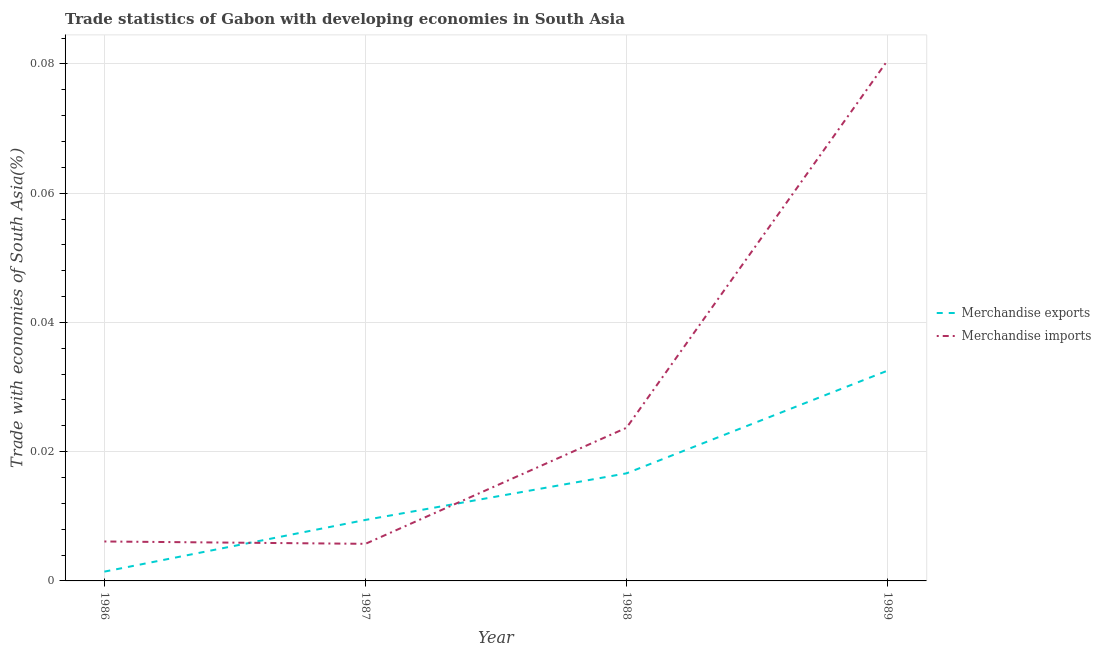How many different coloured lines are there?
Offer a terse response. 2. What is the merchandise exports in 1989?
Give a very brief answer. 0.03. Across all years, what is the maximum merchandise imports?
Your answer should be very brief. 0.08. Across all years, what is the minimum merchandise exports?
Your answer should be very brief. 0. What is the total merchandise imports in the graph?
Your answer should be very brief. 0.12. What is the difference between the merchandise exports in 1988 and that in 1989?
Your response must be concise. -0.02. What is the difference between the merchandise imports in 1988 and the merchandise exports in 1987?
Offer a very short reply. 0.01. What is the average merchandise exports per year?
Keep it short and to the point. 0.02. In the year 1986, what is the difference between the merchandise exports and merchandise imports?
Your answer should be compact. -0. What is the ratio of the merchandise exports in 1987 to that in 1989?
Make the answer very short. 0.29. Is the difference between the merchandise exports in 1987 and 1989 greater than the difference between the merchandise imports in 1987 and 1989?
Ensure brevity in your answer.  Yes. What is the difference between the highest and the second highest merchandise exports?
Provide a short and direct response. 0.02. What is the difference between the highest and the lowest merchandise imports?
Give a very brief answer. 0.07. Is the merchandise exports strictly less than the merchandise imports over the years?
Make the answer very short. No. How many lines are there?
Your answer should be very brief. 2. What is the difference between two consecutive major ticks on the Y-axis?
Provide a short and direct response. 0.02. Does the graph contain any zero values?
Make the answer very short. No. Does the graph contain grids?
Make the answer very short. Yes. Where does the legend appear in the graph?
Provide a succinct answer. Center right. How many legend labels are there?
Ensure brevity in your answer.  2. What is the title of the graph?
Keep it short and to the point. Trade statistics of Gabon with developing economies in South Asia. Does "Overweight" appear as one of the legend labels in the graph?
Provide a succinct answer. No. What is the label or title of the X-axis?
Your answer should be compact. Year. What is the label or title of the Y-axis?
Make the answer very short. Trade with economies of South Asia(%). What is the Trade with economies of South Asia(%) in Merchandise exports in 1986?
Provide a short and direct response. 0. What is the Trade with economies of South Asia(%) of Merchandise imports in 1986?
Make the answer very short. 0.01. What is the Trade with economies of South Asia(%) of Merchandise exports in 1987?
Ensure brevity in your answer.  0.01. What is the Trade with economies of South Asia(%) of Merchandise imports in 1987?
Ensure brevity in your answer.  0.01. What is the Trade with economies of South Asia(%) in Merchandise exports in 1988?
Provide a succinct answer. 0.02. What is the Trade with economies of South Asia(%) of Merchandise imports in 1988?
Your answer should be very brief. 0.02. What is the Trade with economies of South Asia(%) of Merchandise exports in 1989?
Your answer should be very brief. 0.03. What is the Trade with economies of South Asia(%) in Merchandise imports in 1989?
Your response must be concise. 0.08. Across all years, what is the maximum Trade with economies of South Asia(%) of Merchandise exports?
Your response must be concise. 0.03. Across all years, what is the maximum Trade with economies of South Asia(%) in Merchandise imports?
Ensure brevity in your answer.  0.08. Across all years, what is the minimum Trade with economies of South Asia(%) in Merchandise exports?
Make the answer very short. 0. Across all years, what is the minimum Trade with economies of South Asia(%) of Merchandise imports?
Offer a very short reply. 0.01. What is the total Trade with economies of South Asia(%) in Merchandise exports in the graph?
Your response must be concise. 0.06. What is the total Trade with economies of South Asia(%) of Merchandise imports in the graph?
Give a very brief answer. 0.12. What is the difference between the Trade with economies of South Asia(%) in Merchandise exports in 1986 and that in 1987?
Provide a succinct answer. -0.01. What is the difference between the Trade with economies of South Asia(%) in Merchandise exports in 1986 and that in 1988?
Your answer should be very brief. -0.02. What is the difference between the Trade with economies of South Asia(%) of Merchandise imports in 1986 and that in 1988?
Make the answer very short. -0.02. What is the difference between the Trade with economies of South Asia(%) of Merchandise exports in 1986 and that in 1989?
Ensure brevity in your answer.  -0.03. What is the difference between the Trade with economies of South Asia(%) of Merchandise imports in 1986 and that in 1989?
Make the answer very short. -0.07. What is the difference between the Trade with economies of South Asia(%) in Merchandise exports in 1987 and that in 1988?
Your answer should be compact. -0.01. What is the difference between the Trade with economies of South Asia(%) in Merchandise imports in 1987 and that in 1988?
Make the answer very short. -0.02. What is the difference between the Trade with economies of South Asia(%) in Merchandise exports in 1987 and that in 1989?
Offer a terse response. -0.02. What is the difference between the Trade with economies of South Asia(%) of Merchandise imports in 1987 and that in 1989?
Keep it short and to the point. -0.07. What is the difference between the Trade with economies of South Asia(%) in Merchandise exports in 1988 and that in 1989?
Keep it short and to the point. -0.02. What is the difference between the Trade with economies of South Asia(%) in Merchandise imports in 1988 and that in 1989?
Ensure brevity in your answer.  -0.06. What is the difference between the Trade with economies of South Asia(%) in Merchandise exports in 1986 and the Trade with economies of South Asia(%) in Merchandise imports in 1987?
Keep it short and to the point. -0. What is the difference between the Trade with economies of South Asia(%) in Merchandise exports in 1986 and the Trade with economies of South Asia(%) in Merchandise imports in 1988?
Your answer should be very brief. -0.02. What is the difference between the Trade with economies of South Asia(%) of Merchandise exports in 1986 and the Trade with economies of South Asia(%) of Merchandise imports in 1989?
Your answer should be compact. -0.08. What is the difference between the Trade with economies of South Asia(%) in Merchandise exports in 1987 and the Trade with economies of South Asia(%) in Merchandise imports in 1988?
Give a very brief answer. -0.01. What is the difference between the Trade with economies of South Asia(%) in Merchandise exports in 1987 and the Trade with economies of South Asia(%) in Merchandise imports in 1989?
Your answer should be compact. -0.07. What is the difference between the Trade with economies of South Asia(%) of Merchandise exports in 1988 and the Trade with economies of South Asia(%) of Merchandise imports in 1989?
Offer a terse response. -0.06. What is the average Trade with economies of South Asia(%) in Merchandise exports per year?
Provide a succinct answer. 0.01. What is the average Trade with economies of South Asia(%) in Merchandise imports per year?
Keep it short and to the point. 0.03. In the year 1986, what is the difference between the Trade with economies of South Asia(%) in Merchandise exports and Trade with economies of South Asia(%) in Merchandise imports?
Your answer should be compact. -0. In the year 1987, what is the difference between the Trade with economies of South Asia(%) in Merchandise exports and Trade with economies of South Asia(%) in Merchandise imports?
Your response must be concise. 0. In the year 1988, what is the difference between the Trade with economies of South Asia(%) in Merchandise exports and Trade with economies of South Asia(%) in Merchandise imports?
Offer a terse response. -0.01. In the year 1989, what is the difference between the Trade with economies of South Asia(%) of Merchandise exports and Trade with economies of South Asia(%) of Merchandise imports?
Your response must be concise. -0.05. What is the ratio of the Trade with economies of South Asia(%) of Merchandise exports in 1986 to that in 1987?
Your answer should be very brief. 0.15. What is the ratio of the Trade with economies of South Asia(%) in Merchandise imports in 1986 to that in 1987?
Offer a very short reply. 1.06. What is the ratio of the Trade with economies of South Asia(%) in Merchandise exports in 1986 to that in 1988?
Your answer should be compact. 0.09. What is the ratio of the Trade with economies of South Asia(%) in Merchandise imports in 1986 to that in 1988?
Your answer should be very brief. 0.26. What is the ratio of the Trade with economies of South Asia(%) in Merchandise exports in 1986 to that in 1989?
Your answer should be very brief. 0.04. What is the ratio of the Trade with economies of South Asia(%) of Merchandise imports in 1986 to that in 1989?
Give a very brief answer. 0.08. What is the ratio of the Trade with economies of South Asia(%) of Merchandise exports in 1987 to that in 1988?
Offer a terse response. 0.57. What is the ratio of the Trade with economies of South Asia(%) of Merchandise imports in 1987 to that in 1988?
Keep it short and to the point. 0.24. What is the ratio of the Trade with economies of South Asia(%) in Merchandise exports in 1987 to that in 1989?
Offer a very short reply. 0.29. What is the ratio of the Trade with economies of South Asia(%) in Merchandise imports in 1987 to that in 1989?
Give a very brief answer. 0.07. What is the ratio of the Trade with economies of South Asia(%) of Merchandise exports in 1988 to that in 1989?
Your answer should be compact. 0.51. What is the ratio of the Trade with economies of South Asia(%) of Merchandise imports in 1988 to that in 1989?
Keep it short and to the point. 0.29. What is the difference between the highest and the second highest Trade with economies of South Asia(%) in Merchandise exports?
Your answer should be very brief. 0.02. What is the difference between the highest and the second highest Trade with economies of South Asia(%) in Merchandise imports?
Ensure brevity in your answer.  0.06. What is the difference between the highest and the lowest Trade with economies of South Asia(%) of Merchandise exports?
Keep it short and to the point. 0.03. What is the difference between the highest and the lowest Trade with economies of South Asia(%) of Merchandise imports?
Your answer should be very brief. 0.07. 